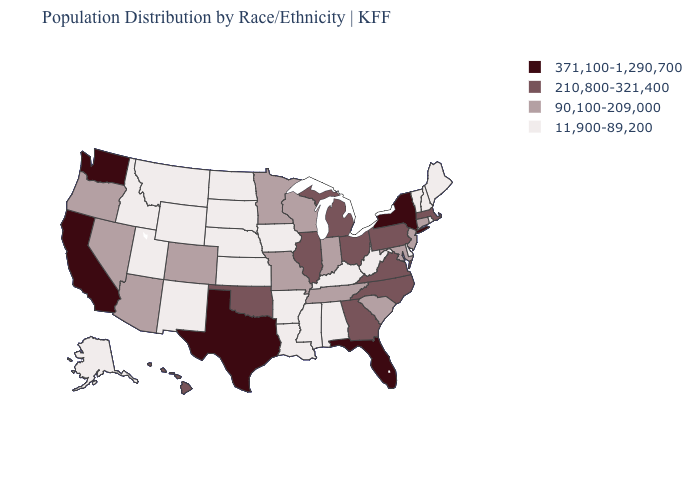What is the value of Indiana?
Concise answer only. 90,100-209,000. How many symbols are there in the legend?
Short answer required. 4. Name the states that have a value in the range 11,900-89,200?
Quick response, please. Alabama, Alaska, Arkansas, Delaware, Idaho, Iowa, Kansas, Kentucky, Louisiana, Maine, Mississippi, Montana, Nebraska, New Hampshire, New Mexico, North Dakota, Rhode Island, South Dakota, Utah, Vermont, West Virginia, Wyoming. What is the highest value in the MidWest ?
Be succinct. 210,800-321,400. Name the states that have a value in the range 11,900-89,200?
Give a very brief answer. Alabama, Alaska, Arkansas, Delaware, Idaho, Iowa, Kansas, Kentucky, Louisiana, Maine, Mississippi, Montana, Nebraska, New Hampshire, New Mexico, North Dakota, Rhode Island, South Dakota, Utah, Vermont, West Virginia, Wyoming. What is the lowest value in the Northeast?
Be succinct. 11,900-89,200. Is the legend a continuous bar?
Concise answer only. No. What is the lowest value in the Northeast?
Keep it brief. 11,900-89,200. Does Florida have a higher value than Washington?
Give a very brief answer. No. Name the states that have a value in the range 210,800-321,400?
Answer briefly. Georgia, Hawaii, Illinois, Massachusetts, Michigan, North Carolina, Ohio, Oklahoma, Pennsylvania, Virginia. What is the value of Wyoming?
Be succinct. 11,900-89,200. What is the highest value in the South ?
Answer briefly. 371,100-1,290,700. Among the states that border South Carolina , which have the lowest value?
Answer briefly. Georgia, North Carolina. Name the states that have a value in the range 90,100-209,000?
Be succinct. Arizona, Colorado, Connecticut, Indiana, Maryland, Minnesota, Missouri, Nevada, New Jersey, Oregon, South Carolina, Tennessee, Wisconsin. What is the lowest value in states that border Washington?
Concise answer only. 11,900-89,200. 